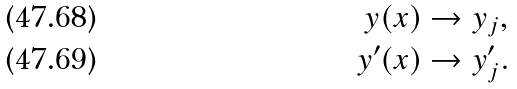<formula> <loc_0><loc_0><loc_500><loc_500>y ( x ) & \rightarrow y _ { j } , \\ y ^ { \prime } ( x ) & \rightarrow y ^ { \prime } _ { j } .</formula> 